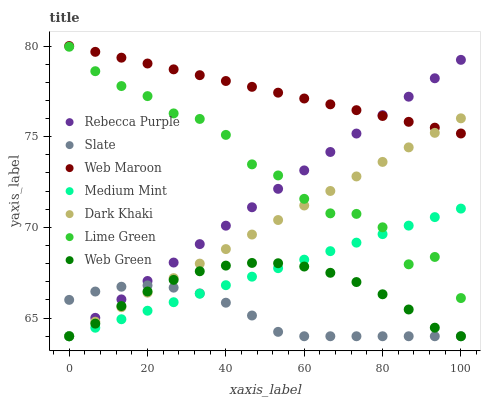Does Slate have the minimum area under the curve?
Answer yes or no. Yes. Does Web Maroon have the maximum area under the curve?
Answer yes or no. Yes. Does Web Maroon have the minimum area under the curve?
Answer yes or no. No. Does Slate have the maximum area under the curve?
Answer yes or no. No. Is Rebecca Purple the smoothest?
Answer yes or no. Yes. Is Lime Green the roughest?
Answer yes or no. Yes. Is Slate the smoothest?
Answer yes or no. No. Is Slate the roughest?
Answer yes or no. No. Does Medium Mint have the lowest value?
Answer yes or no. Yes. Does Web Maroon have the lowest value?
Answer yes or no. No. Does Web Maroon have the highest value?
Answer yes or no. Yes. Does Slate have the highest value?
Answer yes or no. No. Is Medium Mint less than Web Maroon?
Answer yes or no. Yes. Is Web Maroon greater than Web Green?
Answer yes or no. Yes. Does Dark Khaki intersect Lime Green?
Answer yes or no. Yes. Is Dark Khaki less than Lime Green?
Answer yes or no. No. Is Dark Khaki greater than Lime Green?
Answer yes or no. No. Does Medium Mint intersect Web Maroon?
Answer yes or no. No. 